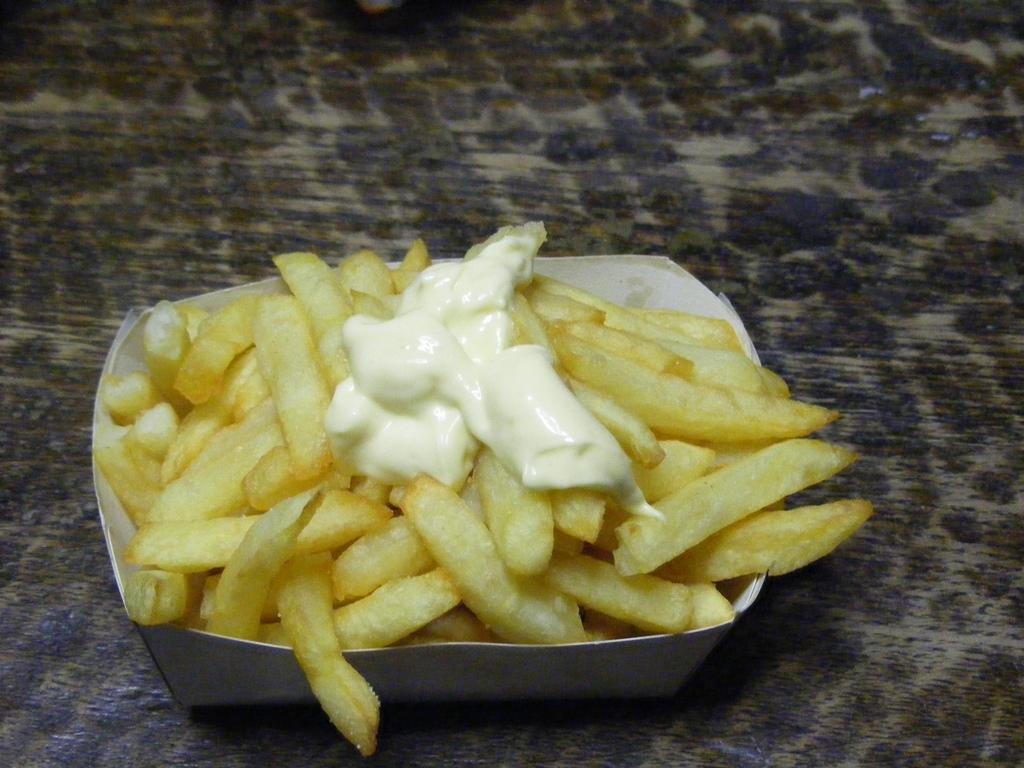What type of items can be seen in the image? There are food items in the image. How are the food items arranged or contained? The food items are in a box. Where is the box with the food items located? The box is on a surface. What is the opinion of the food items about the current political climate? Food items do not have opinions, as they are inanimate objects. 